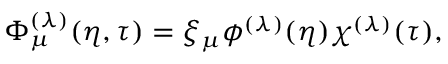Convert formula to latex. <formula><loc_0><loc_0><loc_500><loc_500>\Phi _ { \mu } ^ { ( \lambda ) } ( \eta , \tau ) = \xi _ { \mu } \phi ^ { ( \lambda ) } ( \eta ) \chi ^ { ( \lambda ) } ( \tau ) ,</formula> 